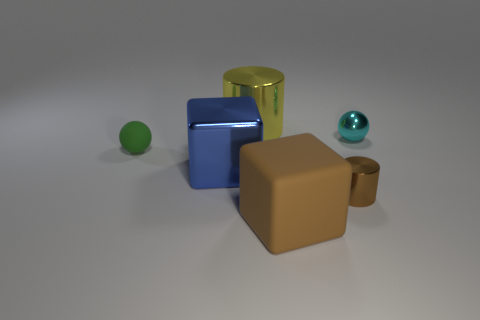What is the color of the matte thing that is the same size as the blue metallic thing?
Provide a succinct answer. Brown. What number of other things are the same shape as the tiny cyan shiny object?
Make the answer very short. 1. Are there any cyan things made of the same material as the green object?
Give a very brief answer. No. Is the material of the sphere that is on the right side of the brown cube the same as the block to the left of the large rubber block?
Your answer should be compact. Yes. What number of small gray metal cylinders are there?
Offer a very short reply. 0. There is a blue object that is behind the small brown metallic object; what shape is it?
Make the answer very short. Cube. What number of other things are there of the same size as the brown cylinder?
Your answer should be compact. 2. Do the matte thing in front of the large blue metallic block and the large metal object behind the cyan sphere have the same shape?
Your answer should be compact. No. There is a tiny green rubber ball; how many balls are on the right side of it?
Your answer should be compact. 1. There is a large metallic thing that is behind the small cyan object; what is its color?
Provide a succinct answer. Yellow. 